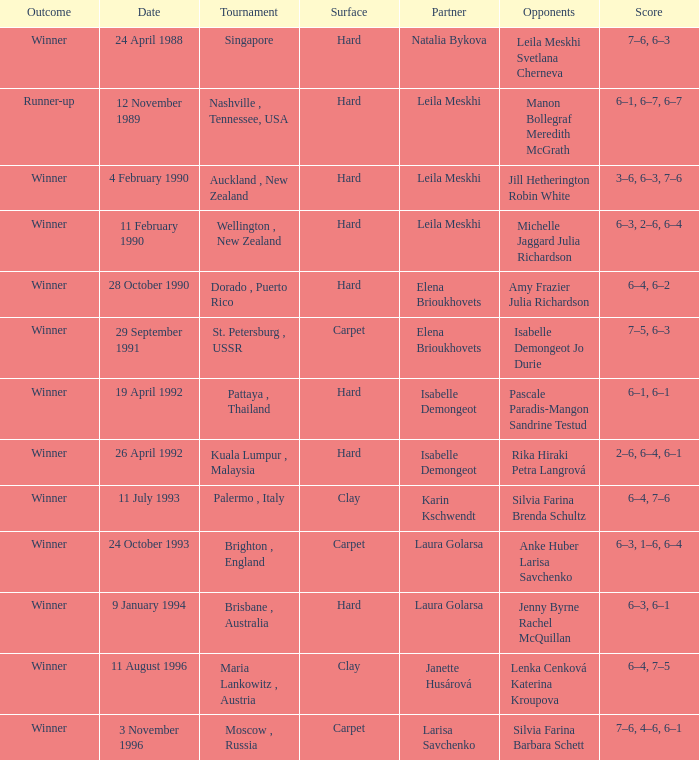On which date was the score 6-4, 6-2? 28 October 1990. 